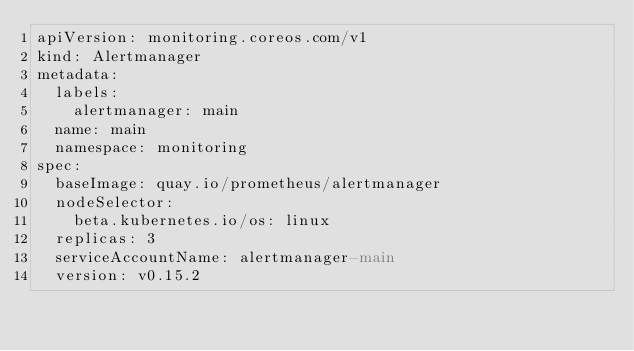Convert code to text. <code><loc_0><loc_0><loc_500><loc_500><_YAML_>apiVersion: monitoring.coreos.com/v1
kind: Alertmanager
metadata:
  labels:
    alertmanager: main
  name: main
  namespace: monitoring
spec:
  baseImage: quay.io/prometheus/alertmanager
  nodeSelector:
    beta.kubernetes.io/os: linux
  replicas: 3
  serviceAccountName: alertmanager-main
  version: v0.15.2
</code> 